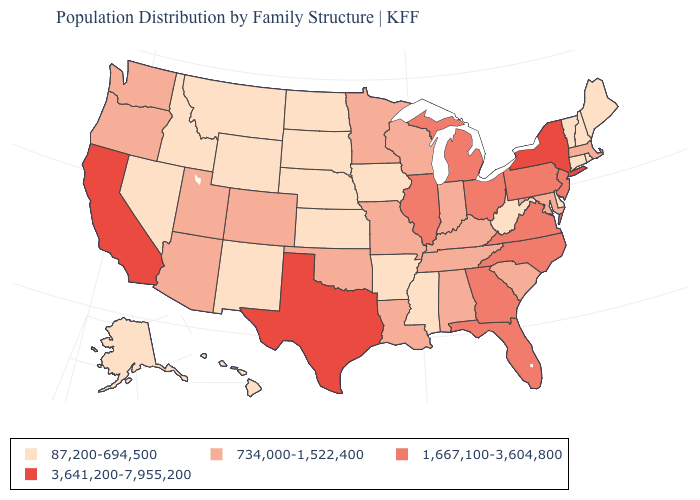Which states hav the highest value in the MidWest?
Answer briefly. Illinois, Michigan, Ohio. Name the states that have a value in the range 734,000-1,522,400?
Quick response, please. Alabama, Arizona, Colorado, Indiana, Kentucky, Louisiana, Maryland, Massachusetts, Minnesota, Missouri, Oklahoma, Oregon, South Carolina, Tennessee, Utah, Washington, Wisconsin. Which states hav the highest value in the MidWest?
Keep it brief. Illinois, Michigan, Ohio. Does the first symbol in the legend represent the smallest category?
Write a very short answer. Yes. Which states have the lowest value in the USA?
Keep it brief. Alaska, Arkansas, Connecticut, Delaware, Hawaii, Idaho, Iowa, Kansas, Maine, Mississippi, Montana, Nebraska, Nevada, New Hampshire, New Mexico, North Dakota, Rhode Island, South Dakota, Vermont, West Virginia, Wyoming. What is the lowest value in states that border North Carolina?
Quick response, please. 734,000-1,522,400. Which states have the lowest value in the South?
Short answer required. Arkansas, Delaware, Mississippi, West Virginia. Name the states that have a value in the range 87,200-694,500?
Quick response, please. Alaska, Arkansas, Connecticut, Delaware, Hawaii, Idaho, Iowa, Kansas, Maine, Mississippi, Montana, Nebraska, Nevada, New Hampshire, New Mexico, North Dakota, Rhode Island, South Dakota, Vermont, West Virginia, Wyoming. Does the map have missing data?
Give a very brief answer. No. Name the states that have a value in the range 1,667,100-3,604,800?
Concise answer only. Florida, Georgia, Illinois, Michigan, New Jersey, North Carolina, Ohio, Pennsylvania, Virginia. Name the states that have a value in the range 3,641,200-7,955,200?
Short answer required. California, New York, Texas. What is the value of Kentucky?
Keep it brief. 734,000-1,522,400. Does the map have missing data?
Keep it brief. No. Name the states that have a value in the range 734,000-1,522,400?
Give a very brief answer. Alabama, Arizona, Colorado, Indiana, Kentucky, Louisiana, Maryland, Massachusetts, Minnesota, Missouri, Oklahoma, Oregon, South Carolina, Tennessee, Utah, Washington, Wisconsin. Does West Virginia have the lowest value in the South?
Answer briefly. Yes. 